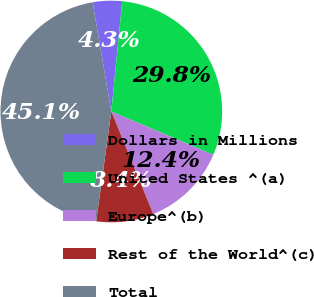Convert chart to OTSL. <chart><loc_0><loc_0><loc_500><loc_500><pie_chart><fcel>Dollars in Millions<fcel>United States ^(a)<fcel>Europe^(b)<fcel>Rest of the World^(c)<fcel>Total<nl><fcel>4.27%<fcel>29.82%<fcel>12.44%<fcel>8.36%<fcel>45.12%<nl></chart> 